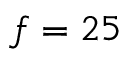Convert formula to latex. <formula><loc_0><loc_0><loc_500><loc_500>f = 2 5</formula> 